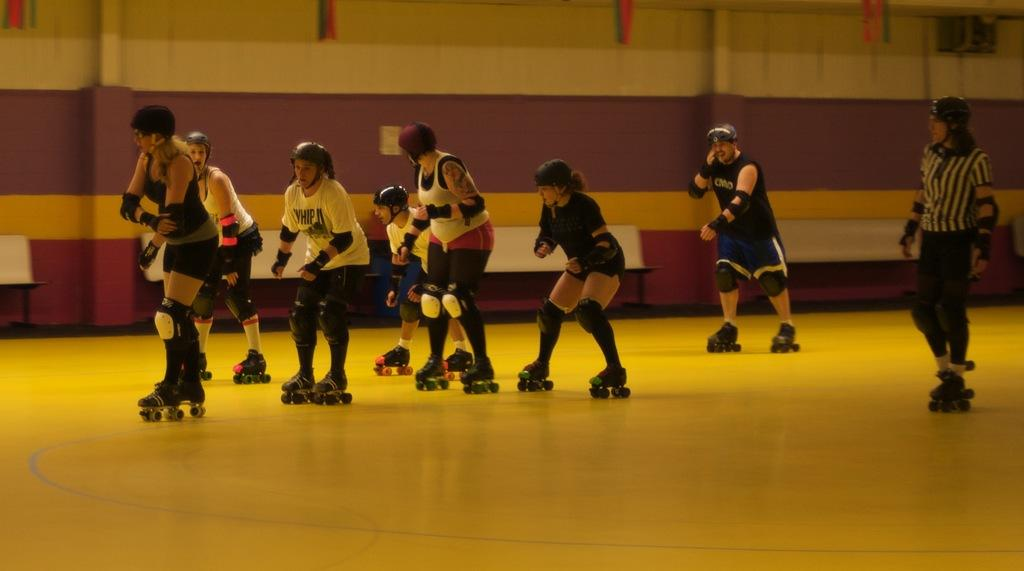Who or what can be seen in the image? There are persons in the image. What are the persons wearing? The persons are wearing clothes. What activity are the persons engaged in? The persons are skating on the floor. What type of furniture is present in the image? There are benches in front of the wall in the image. What type of farm animals can be seen in the image? There are no farm animals present in the image. How do the persons in the image show respect to each other? The image does not provide information about how the persons show respect to each other. 